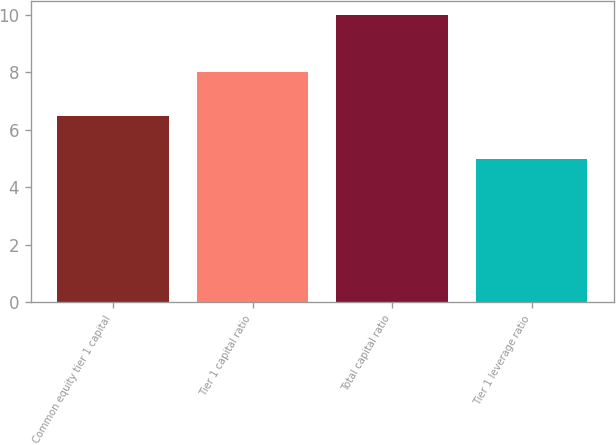Convert chart to OTSL. <chart><loc_0><loc_0><loc_500><loc_500><bar_chart><fcel>Common equity tier 1 capital<fcel>Tier 1 capital ratio<fcel>Total capital ratio<fcel>Tier 1 leverage ratio<nl><fcel>6.5<fcel>8<fcel>10<fcel>5<nl></chart> 